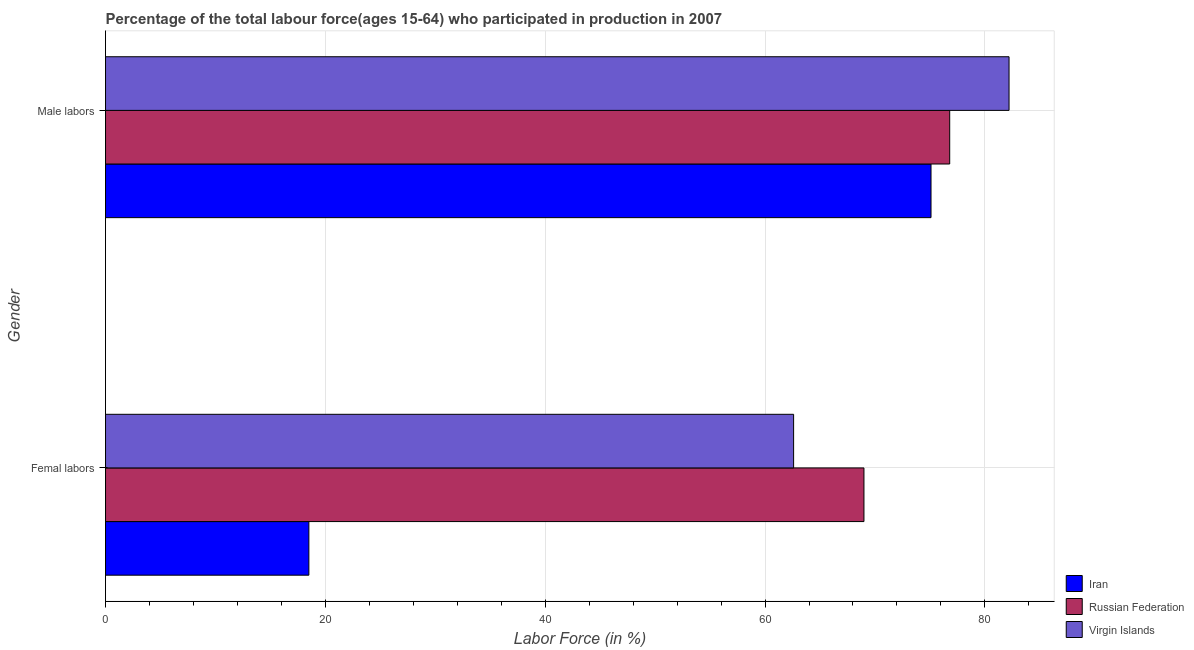How many different coloured bars are there?
Ensure brevity in your answer.  3. Are the number of bars per tick equal to the number of legend labels?
Provide a short and direct response. Yes. Are the number of bars on each tick of the Y-axis equal?
Your answer should be very brief. Yes. How many bars are there on the 1st tick from the top?
Ensure brevity in your answer.  3. What is the label of the 2nd group of bars from the top?
Provide a short and direct response. Femal labors. What is the percentage of male labour force in Iran?
Your answer should be very brief. 75.1. In which country was the percentage of female labor force maximum?
Ensure brevity in your answer.  Russian Federation. In which country was the percentage of male labour force minimum?
Ensure brevity in your answer.  Iran. What is the total percentage of male labour force in the graph?
Offer a very short reply. 234.1. What is the difference between the percentage of male labour force in Russian Federation and that in Iran?
Keep it short and to the point. 1.7. What is the difference between the percentage of male labour force in Virgin Islands and the percentage of female labor force in Iran?
Your answer should be very brief. 63.7. What is the average percentage of male labour force per country?
Provide a succinct answer. 78.03. What is the difference between the percentage of female labor force and percentage of male labour force in Iran?
Keep it short and to the point. -56.6. What is the ratio of the percentage of female labor force in Iran to that in Russian Federation?
Your response must be concise. 0.27. Is the percentage of male labour force in Iran less than that in Russian Federation?
Ensure brevity in your answer.  Yes. In how many countries, is the percentage of male labour force greater than the average percentage of male labour force taken over all countries?
Make the answer very short. 1. What does the 1st bar from the top in Male labors represents?
Offer a very short reply. Virgin Islands. What does the 1st bar from the bottom in Femal labors represents?
Your answer should be compact. Iran. How many bars are there?
Provide a succinct answer. 6. Are all the bars in the graph horizontal?
Your answer should be compact. Yes. What is the difference between two consecutive major ticks on the X-axis?
Give a very brief answer. 20. Does the graph contain grids?
Offer a terse response. Yes. Where does the legend appear in the graph?
Ensure brevity in your answer.  Bottom right. How many legend labels are there?
Offer a terse response. 3. What is the title of the graph?
Offer a very short reply. Percentage of the total labour force(ages 15-64) who participated in production in 2007. Does "Madagascar" appear as one of the legend labels in the graph?
Your answer should be very brief. No. What is the label or title of the X-axis?
Provide a succinct answer. Labor Force (in %). What is the label or title of the Y-axis?
Provide a succinct answer. Gender. What is the Labor Force (in %) in Iran in Femal labors?
Provide a short and direct response. 18.5. What is the Labor Force (in %) of Virgin Islands in Femal labors?
Keep it short and to the point. 62.6. What is the Labor Force (in %) in Iran in Male labors?
Provide a short and direct response. 75.1. What is the Labor Force (in %) in Russian Federation in Male labors?
Ensure brevity in your answer.  76.8. What is the Labor Force (in %) in Virgin Islands in Male labors?
Your answer should be very brief. 82.2. Across all Gender, what is the maximum Labor Force (in %) in Iran?
Make the answer very short. 75.1. Across all Gender, what is the maximum Labor Force (in %) of Russian Federation?
Make the answer very short. 76.8. Across all Gender, what is the maximum Labor Force (in %) of Virgin Islands?
Make the answer very short. 82.2. Across all Gender, what is the minimum Labor Force (in %) in Iran?
Your answer should be compact. 18.5. Across all Gender, what is the minimum Labor Force (in %) in Virgin Islands?
Keep it short and to the point. 62.6. What is the total Labor Force (in %) of Iran in the graph?
Give a very brief answer. 93.6. What is the total Labor Force (in %) in Russian Federation in the graph?
Give a very brief answer. 145.8. What is the total Labor Force (in %) of Virgin Islands in the graph?
Offer a terse response. 144.8. What is the difference between the Labor Force (in %) of Iran in Femal labors and that in Male labors?
Your answer should be very brief. -56.6. What is the difference between the Labor Force (in %) in Virgin Islands in Femal labors and that in Male labors?
Keep it short and to the point. -19.6. What is the difference between the Labor Force (in %) in Iran in Femal labors and the Labor Force (in %) in Russian Federation in Male labors?
Offer a very short reply. -58.3. What is the difference between the Labor Force (in %) in Iran in Femal labors and the Labor Force (in %) in Virgin Islands in Male labors?
Make the answer very short. -63.7. What is the difference between the Labor Force (in %) of Russian Federation in Femal labors and the Labor Force (in %) of Virgin Islands in Male labors?
Provide a short and direct response. -13.2. What is the average Labor Force (in %) of Iran per Gender?
Ensure brevity in your answer.  46.8. What is the average Labor Force (in %) of Russian Federation per Gender?
Give a very brief answer. 72.9. What is the average Labor Force (in %) in Virgin Islands per Gender?
Ensure brevity in your answer.  72.4. What is the difference between the Labor Force (in %) in Iran and Labor Force (in %) in Russian Federation in Femal labors?
Keep it short and to the point. -50.5. What is the difference between the Labor Force (in %) of Iran and Labor Force (in %) of Virgin Islands in Femal labors?
Make the answer very short. -44.1. What is the difference between the Labor Force (in %) of Russian Federation and Labor Force (in %) of Virgin Islands in Femal labors?
Ensure brevity in your answer.  6.4. What is the difference between the Labor Force (in %) in Iran and Labor Force (in %) in Russian Federation in Male labors?
Provide a short and direct response. -1.7. What is the difference between the Labor Force (in %) of Iran and Labor Force (in %) of Virgin Islands in Male labors?
Provide a succinct answer. -7.1. What is the ratio of the Labor Force (in %) of Iran in Femal labors to that in Male labors?
Provide a short and direct response. 0.25. What is the ratio of the Labor Force (in %) in Russian Federation in Femal labors to that in Male labors?
Provide a short and direct response. 0.9. What is the ratio of the Labor Force (in %) in Virgin Islands in Femal labors to that in Male labors?
Provide a short and direct response. 0.76. What is the difference between the highest and the second highest Labor Force (in %) of Iran?
Offer a very short reply. 56.6. What is the difference between the highest and the second highest Labor Force (in %) in Russian Federation?
Your answer should be very brief. 7.8. What is the difference between the highest and the second highest Labor Force (in %) in Virgin Islands?
Offer a terse response. 19.6. What is the difference between the highest and the lowest Labor Force (in %) of Iran?
Provide a succinct answer. 56.6. What is the difference between the highest and the lowest Labor Force (in %) in Virgin Islands?
Provide a short and direct response. 19.6. 